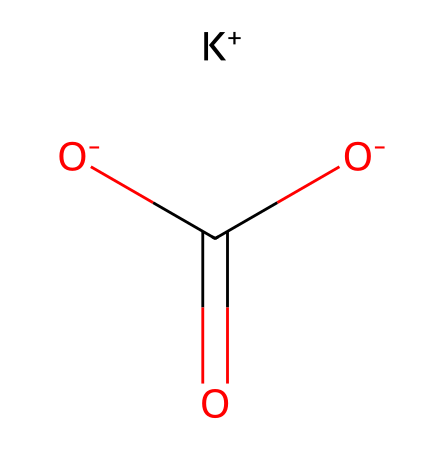what is the molecular formula of potassium bicarbonate? The SMILES representation shows potassium (K) and carbonate (C(=O)[O-]) along with a bicarbonate group, which includes one potassium atom, one carbon atom, and three oxygen atoms. Thus, the molecular formula can be deduced as KHC(=O)[O-].
Answer: KHC(=O)[O-] how many oxygen atoms are present in this chemical structure? Analyzing the SMILES representation, there are two oxygen atoms in the carbonate system (C(=O) and [O-]) and another oxygen from the bicarbonate, totaling three oxygen atoms.
Answer: three which ion in this structure provides basic properties? The presence of the K+ ion signifies that this substance acts as a base in solution, as alkali metal ions typically form neutralizing interactions with acids.
Answer: K+ what is the charge of potassium in this molecule? The notation [K+] indicates a positive charge associated with potassium, which is typical for alkali metal ions and is crucial for its role as an electrolyte.
Answer: positive is potassium bicarbonate an acid or a base? Given the presence of potassium and the bicarbonate component, it can act as a weak base when dissolved in water, though it can also react with acids in neutralization reactions.
Answer: weak base which functional group is indicated by C(=O) and [O-]? In the SMILES representation, the C(=O) indicates a carbonyl functional group and the adjacent [O-] represents a negatively charged oxygen, collectively suggesting a bicarbonate or carbonate presence, which is prevalent in antacids.
Answer: bicarbonate 